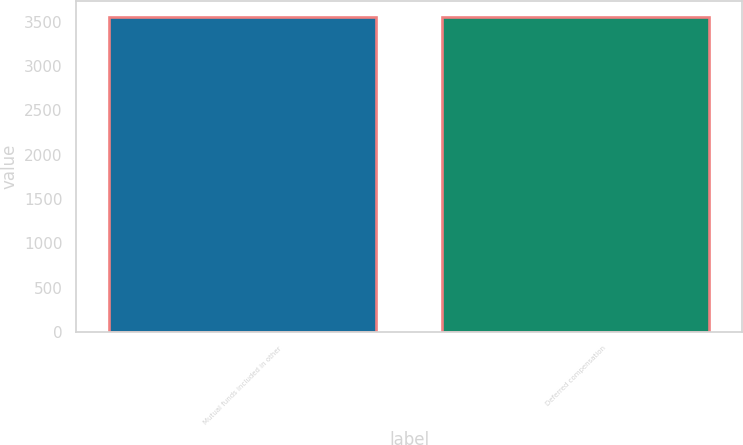<chart> <loc_0><loc_0><loc_500><loc_500><bar_chart><fcel>Mutual funds included in other<fcel>Deferred compensation<nl><fcel>3553<fcel>3553.1<nl></chart> 